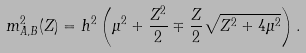<formula> <loc_0><loc_0><loc_500><loc_500>m ^ { 2 } _ { A , B } ( Z ) = h ^ { 2 } \left ( \mu ^ { 2 } + \frac { Z ^ { 2 } } 2 \mp \frac { Z } { 2 } \sqrt { Z ^ { 2 } + 4 \mu ^ { 2 } } \right ) .</formula> 